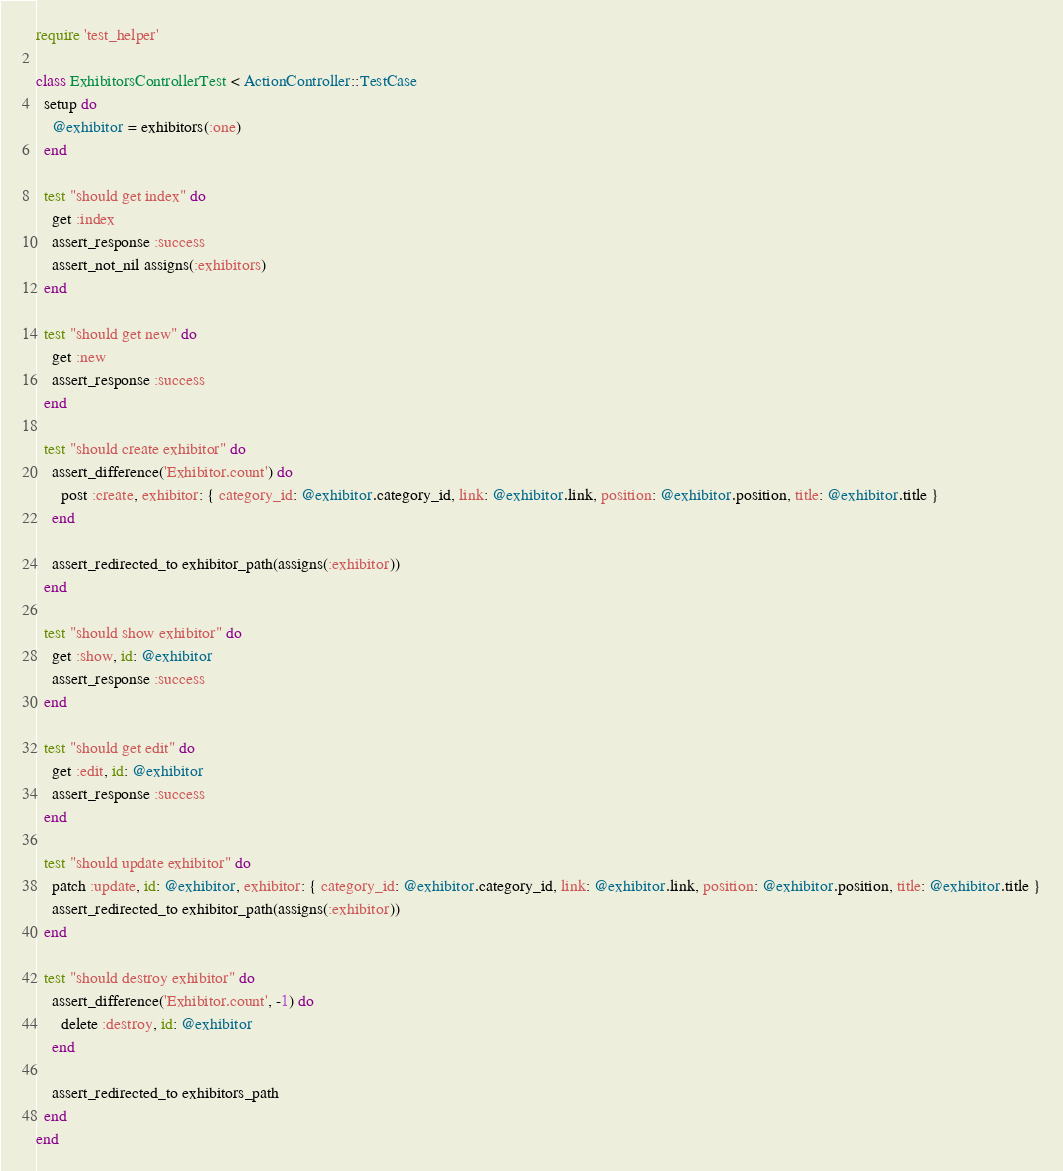Convert code to text. <code><loc_0><loc_0><loc_500><loc_500><_Ruby_>require 'test_helper'

class ExhibitorsControllerTest < ActionController::TestCase
  setup do
    @exhibitor = exhibitors(:one)
  end

  test "should get index" do
    get :index
    assert_response :success
    assert_not_nil assigns(:exhibitors)
  end

  test "should get new" do
    get :new
    assert_response :success
  end

  test "should create exhibitor" do
    assert_difference('Exhibitor.count') do
      post :create, exhibitor: { category_id: @exhibitor.category_id, link: @exhibitor.link, position: @exhibitor.position, title: @exhibitor.title }
    end

    assert_redirected_to exhibitor_path(assigns(:exhibitor))
  end

  test "should show exhibitor" do
    get :show, id: @exhibitor
    assert_response :success
  end

  test "should get edit" do
    get :edit, id: @exhibitor
    assert_response :success
  end

  test "should update exhibitor" do
    patch :update, id: @exhibitor, exhibitor: { category_id: @exhibitor.category_id, link: @exhibitor.link, position: @exhibitor.position, title: @exhibitor.title }
    assert_redirected_to exhibitor_path(assigns(:exhibitor))
  end

  test "should destroy exhibitor" do
    assert_difference('Exhibitor.count', -1) do
      delete :destroy, id: @exhibitor
    end

    assert_redirected_to exhibitors_path
  end
end
</code> 